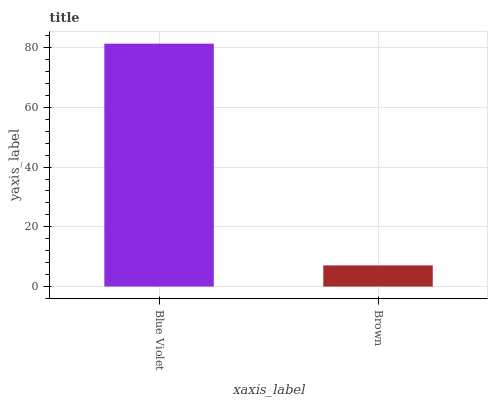Is Brown the minimum?
Answer yes or no. Yes. Is Blue Violet the maximum?
Answer yes or no. Yes. Is Brown the maximum?
Answer yes or no. No. Is Blue Violet greater than Brown?
Answer yes or no. Yes. Is Brown less than Blue Violet?
Answer yes or no. Yes. Is Brown greater than Blue Violet?
Answer yes or no. No. Is Blue Violet less than Brown?
Answer yes or no. No. Is Blue Violet the high median?
Answer yes or no. Yes. Is Brown the low median?
Answer yes or no. Yes. Is Brown the high median?
Answer yes or no. No. Is Blue Violet the low median?
Answer yes or no. No. 